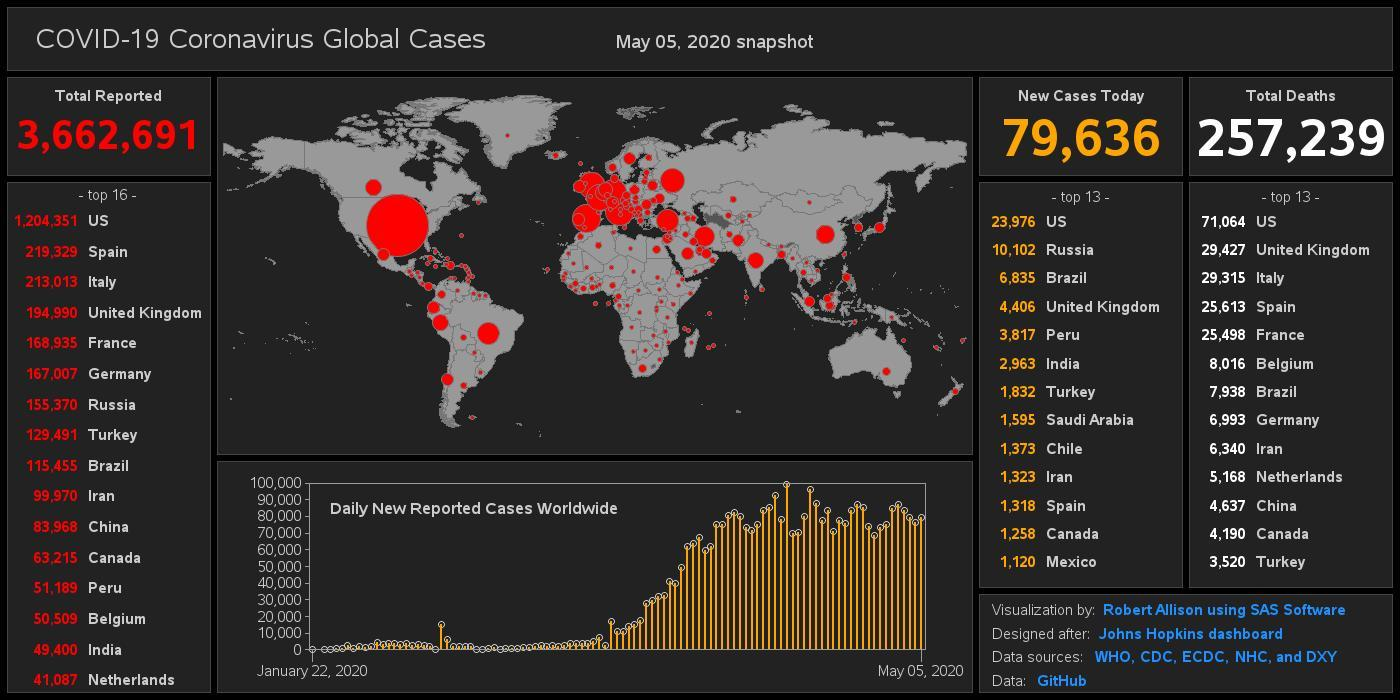Which country has reported the second-highest number of COVID-19 deaths among the top 13 countries as of May 05, 2020?
Answer the question with a short phrase. United Kingdom What is the total number of COVID-19 cases reported globally as of May 05, 2020? 3,662,691 Which country has reported the second-highest number of COVID positive cases among the top 16 countries as of May 05, 2020? Spain How many new cases of Covid-19 were reported in Peru as of May 05, 2020? 3,817 Which country has reported the least number of new COVID-19 cases among the top 13 countries as of May 05, 2020? Mexico Which country has reported the least number of COVID positive cases among the top 16 countries as of May 05, 2020? Netherlands Which country has reported the highest number of COVID-19 deaths among the top 13 countries as of May 05, 2020? US What is the total number of COVID-19 deaths globally? 257,239 How many new cases of Covid-19 were reported in India as of May 05, 2020? 2,963 How many Covid-19 deaths were reported in Italy as of May 05, 2020? 29,315 